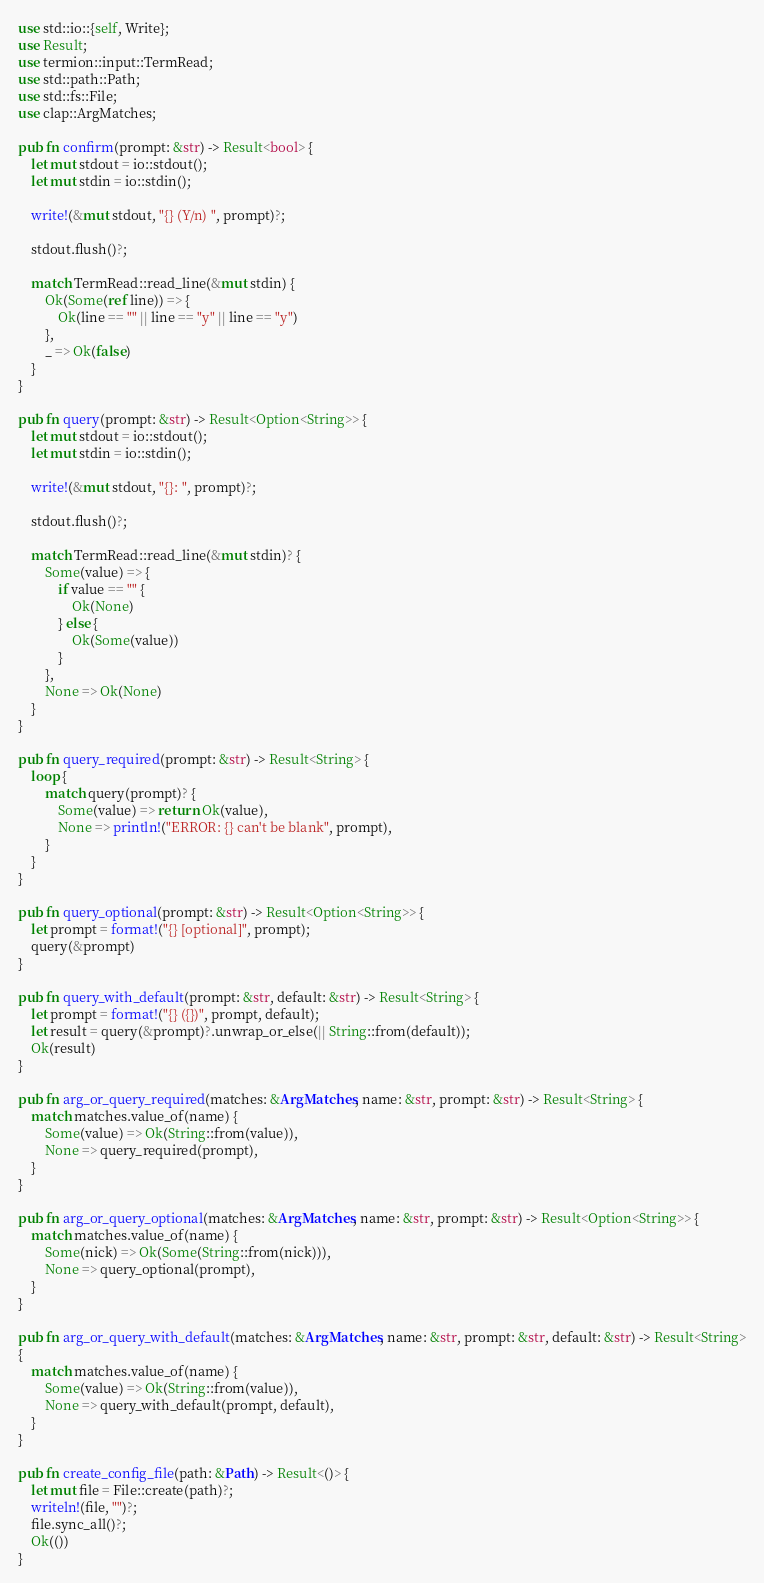Convert code to text. <code><loc_0><loc_0><loc_500><loc_500><_Rust_>use std::io::{self, Write};
use Result;
use termion::input::TermRead;
use std::path::Path;
use std::fs::File;
use clap::ArgMatches;

pub fn confirm(prompt: &str) -> Result<bool> {
    let mut stdout = io::stdout();
    let mut stdin = io::stdin();

    write!(&mut stdout, "{} (Y/n) ", prompt)?;

    stdout.flush()?;

    match TermRead::read_line(&mut stdin) {
        Ok(Some(ref line)) => {
            Ok(line == "" || line == "y" || line == "y")
        },
        _ => Ok(false)
    }
}

pub fn query(prompt: &str) -> Result<Option<String>> {
    let mut stdout = io::stdout();
    let mut stdin = io::stdin();

    write!(&mut stdout, "{}: ", prompt)?;

    stdout.flush()?;

    match TermRead::read_line(&mut stdin)? {
        Some(value) => {
            if value == "" {
                Ok(None)
            } else {
                Ok(Some(value))
            }
        },
        None => Ok(None)
    }
}

pub fn query_required(prompt: &str) -> Result<String> {
    loop {
        match query(prompt)? {
            Some(value) => return Ok(value),
            None => println!("ERROR: {} can't be blank", prompt),
        }
    }
}

pub fn query_optional(prompt: &str) -> Result<Option<String>> {
    let prompt = format!("{} [optional]", prompt);
    query(&prompt)
}

pub fn query_with_default(prompt: &str, default: &str) -> Result<String> {
    let prompt = format!("{} ({})", prompt, default);
    let result = query(&prompt)?.unwrap_or_else(|| String::from(default));
    Ok(result)
}

pub fn arg_or_query_required(matches: &ArgMatches, name: &str, prompt: &str) -> Result<String> {
    match matches.value_of(name) {
        Some(value) => Ok(String::from(value)),
        None => query_required(prompt),
    }
}

pub fn arg_or_query_optional(matches: &ArgMatches, name: &str, prompt: &str) -> Result<Option<String>> {
    match matches.value_of(name) {
        Some(nick) => Ok(Some(String::from(nick))),
        None => query_optional(prompt),
    }
}

pub fn arg_or_query_with_default(matches: &ArgMatches, name: &str, prompt: &str, default: &str) -> Result<String>
{
    match matches.value_of(name) {
        Some(value) => Ok(String::from(value)),
        None => query_with_default(prompt, default),
    }
}

pub fn create_config_file(path: &Path) -> Result<()> {
    let mut file = File::create(path)?;
    writeln!(file, "")?;
    file.sync_all()?;
    Ok(())
}</code> 